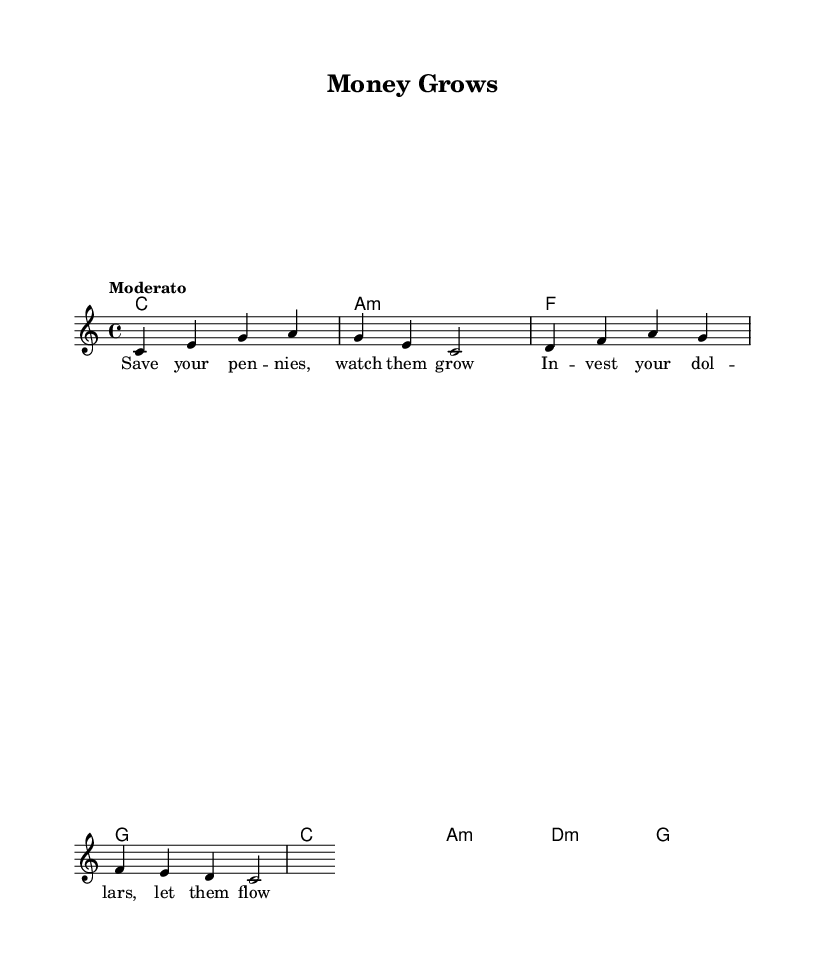What is the key signature of this music? The key signature is C major, which has no sharps or flats.
Answer: C major What is the time signature of this music? The time signature is indicated as 4/4, which means there are four beats in each measure.
Answer: 4/4 What is the tempo marking for this piece? The tempo is marked as "Moderato," which suggests a moderate speed for the performance.
Answer: Moderato How many measures are in the melody? The melody consists of 4 measures, as indicated by the groupings of notes and rests in the staff.
Answer: 4 Which chords are present in the harmonies section? The chords are C, A minor, F, and G, as they appear in the chord names below the staff.
Answer: C, A minor, F, G What lyrical theme does the verse convey? The verse focuses on saving and investing money, particularly for children learning about financial literacy.
Answer: Saving and investing Identify the last note of the melody. The last note of the melody is C, which can be seen at the end of the melody staff.
Answer: C 